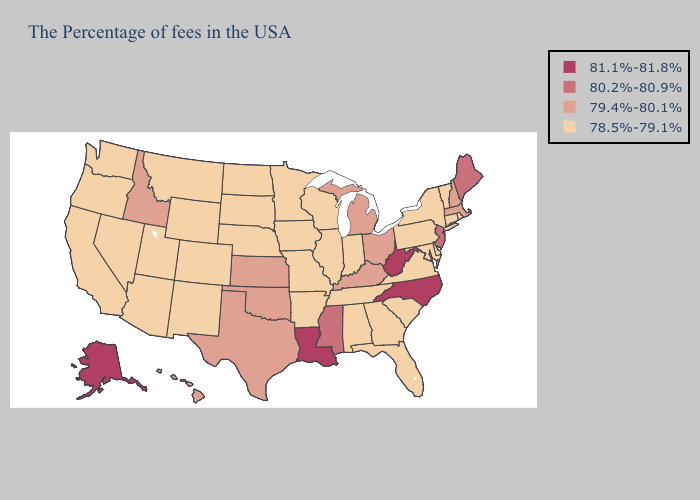What is the value of New Hampshire?
Concise answer only. 79.4%-80.1%. Name the states that have a value in the range 80.2%-80.9%?
Answer briefly. Maine, New Jersey, Mississippi. Does the first symbol in the legend represent the smallest category?
Write a very short answer. No. Among the states that border Kansas , which have the lowest value?
Short answer required. Missouri, Nebraska, Colorado. Which states have the lowest value in the USA?
Give a very brief answer. Rhode Island, Vermont, Connecticut, New York, Delaware, Maryland, Pennsylvania, Virginia, South Carolina, Florida, Georgia, Indiana, Alabama, Tennessee, Wisconsin, Illinois, Missouri, Arkansas, Minnesota, Iowa, Nebraska, South Dakota, North Dakota, Wyoming, Colorado, New Mexico, Utah, Montana, Arizona, Nevada, California, Washington, Oregon. What is the value of Nevada?
Give a very brief answer. 78.5%-79.1%. Among the states that border Maine , which have the highest value?
Give a very brief answer. New Hampshire. Does New Jersey have the highest value in the Northeast?
Give a very brief answer. Yes. Is the legend a continuous bar?
Concise answer only. No. What is the lowest value in states that border Idaho?
Keep it brief. 78.5%-79.1%. What is the value of Alaska?
Quick response, please. 81.1%-81.8%. Which states have the lowest value in the Northeast?
Concise answer only. Rhode Island, Vermont, Connecticut, New York, Pennsylvania. What is the value of Massachusetts?
Give a very brief answer. 79.4%-80.1%. What is the value of Colorado?
Keep it brief. 78.5%-79.1%. What is the value of Utah?
Keep it brief. 78.5%-79.1%. 